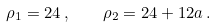<formula> <loc_0><loc_0><loc_500><loc_500>\rho _ { 1 } = 2 4 \, , \quad \rho _ { 2 } = 2 4 + 1 2 a \, .</formula> 